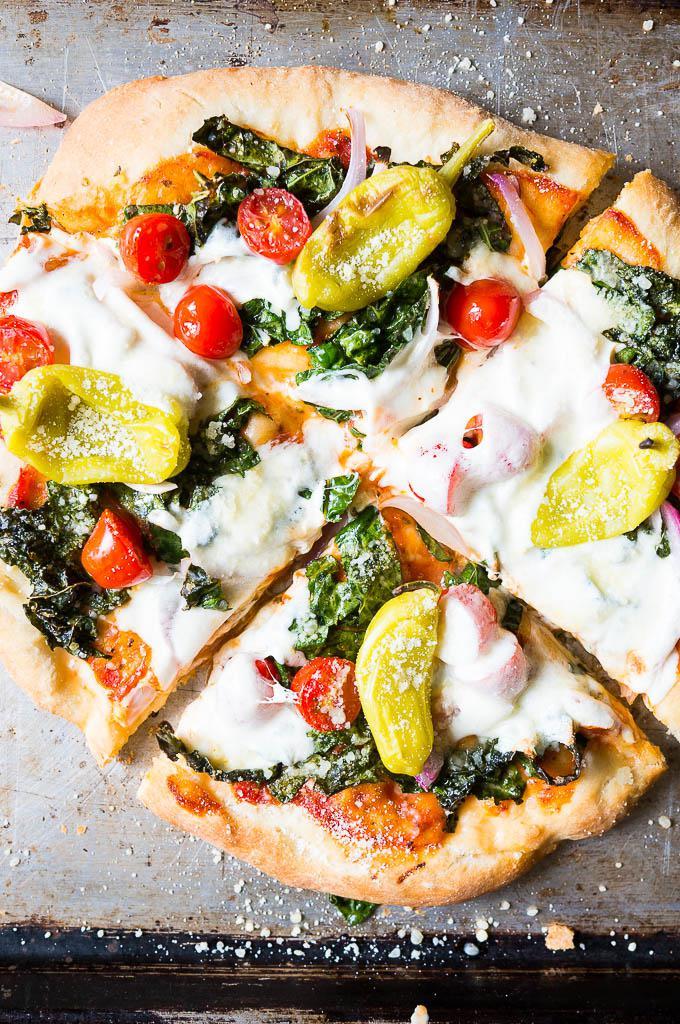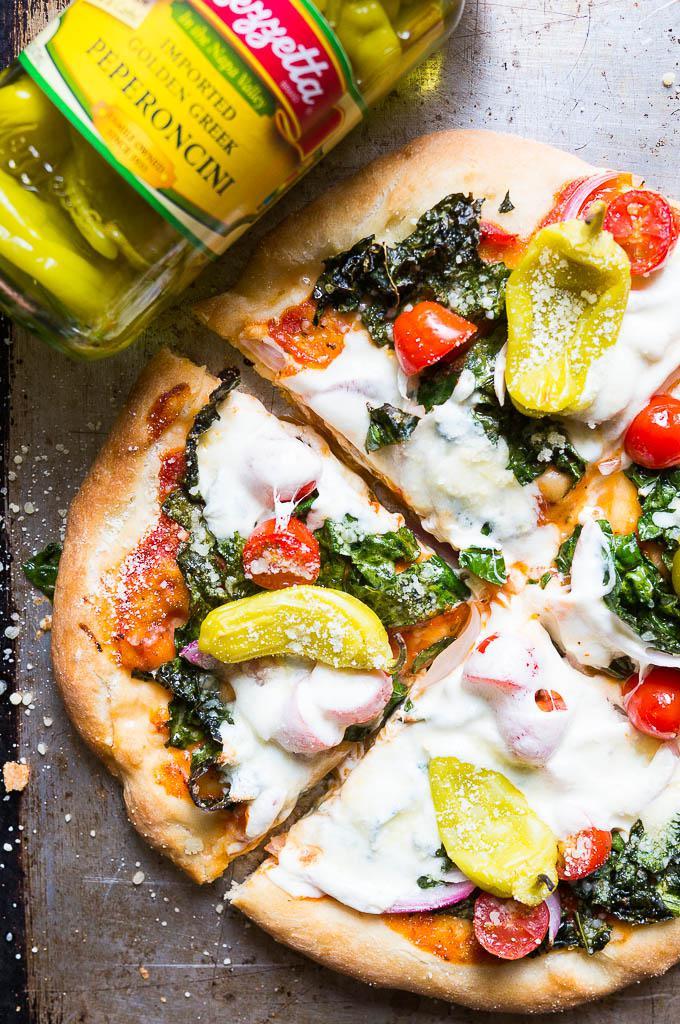The first image is the image on the left, the second image is the image on the right. Given the left and right images, does the statement "The left and right image contains the same number of circle shaped pizzas." hold true? Answer yes or no. Yes. The first image is the image on the left, the second image is the image on the right. Assess this claim about the two images: "The left image contains a round pizza cut in four parts, with a yellowish pepper on top of each slice.". Correct or not? Answer yes or no. Yes. 